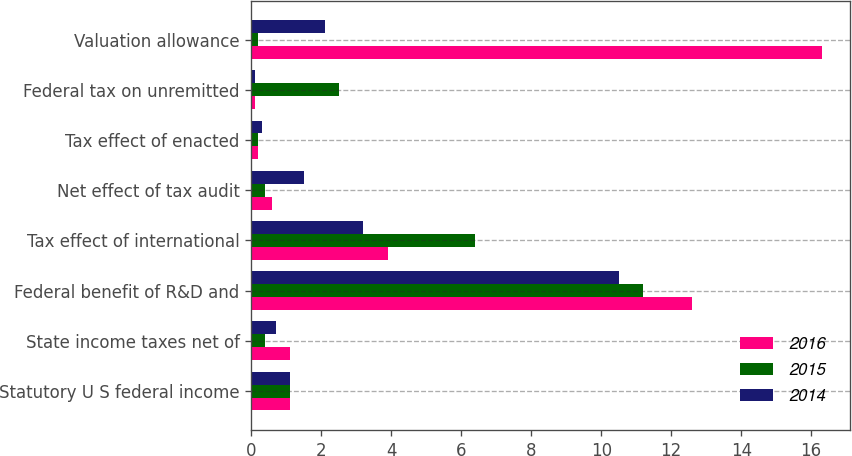Convert chart to OTSL. <chart><loc_0><loc_0><loc_500><loc_500><stacked_bar_chart><ecel><fcel>Statutory U S federal income<fcel>State income taxes net of<fcel>Federal benefit of R&D and<fcel>Tax effect of international<fcel>Net effect of tax audit<fcel>Tax effect of enacted<fcel>Federal tax on unremitted<fcel>Valuation allowance<nl><fcel>2016<fcel>1.1<fcel>1.1<fcel>12.6<fcel>3.9<fcel>0.6<fcel>0.2<fcel>0.1<fcel>16.3<nl><fcel>2015<fcel>1.1<fcel>0.4<fcel>11.2<fcel>6.4<fcel>0.4<fcel>0.2<fcel>2.5<fcel>0.2<nl><fcel>2014<fcel>1.1<fcel>0.7<fcel>10.5<fcel>3.2<fcel>1.5<fcel>0.3<fcel>0.1<fcel>2.1<nl></chart> 